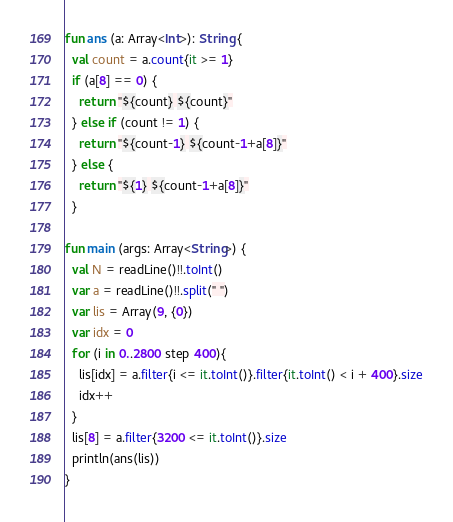<code> <loc_0><loc_0><loc_500><loc_500><_Kotlin_>fun ans (a: Array<Int>): String {
  val count = a.count{it >= 1}
  if (a[8] == 0) {
    return "${count} ${count}"
  } else if (count != 1) {
    return "${count-1} ${count-1+a[8]}"
  } else {
    return "${1} ${count-1+a[8]}"
  }

fun main (args: Array<String>) {
  val N = readLine()!!.toInt()
  var a = readLine()!!.split(" ")
  var lis = Array(9, {0})
  var idx = 0
  for (i in 0..2800 step 400){
    lis[idx] = a.filter{i <= it.toInt()}.filter{it.toInt() < i + 400}.size
    idx++
  }
  lis[8] = a.filter{3200 <= it.toInt()}.size
  println(ans(lis))
}
</code> 